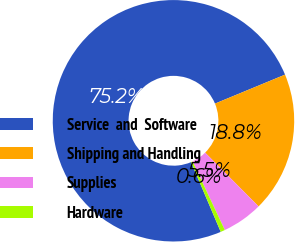Convert chart to OTSL. <chart><loc_0><loc_0><loc_500><loc_500><pie_chart><fcel>Service  and  Software<fcel>Shipping and Handling<fcel>Supplies<fcel>Hardware<nl><fcel>75.16%<fcel>18.79%<fcel>5.46%<fcel>0.59%<nl></chart> 